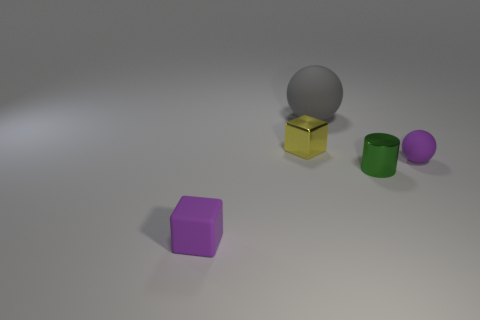Add 5 yellow matte balls. How many objects exist? 10 Subtract all gray balls. How many balls are left? 1 Subtract all cubes. How many objects are left? 3 Add 2 small green objects. How many small green objects exist? 3 Subtract 0 blue blocks. How many objects are left? 5 Subtract all green shiny cylinders. Subtract all small spheres. How many objects are left? 3 Add 4 small purple rubber spheres. How many small purple rubber spheres are left? 5 